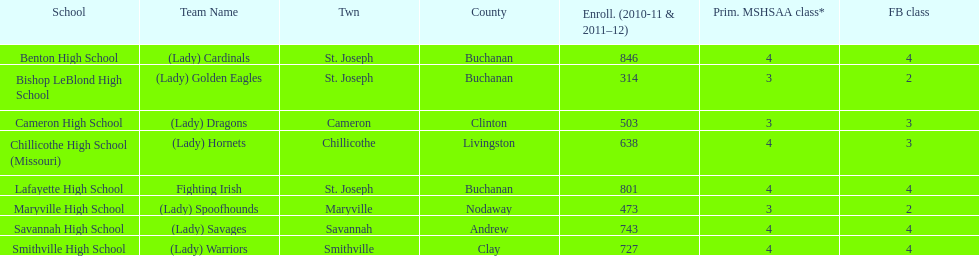Benton high school and bishop leblond high school are both located in what town? St. Joseph. 